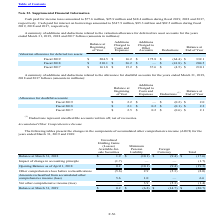According to Microchip Technology's financial document, What do deductions represent? uncollectible accounts written off, net of recoveries. The document states: "(1) Deductions represent uncollectible accounts written off, net of recoveries...." Also, What were the deductions in 2018? According to the financial document, (0.1) (in millions). The relevant text states: "Fiscal 2018 $ 2.1 $ 0.2 $ (0.1) $ 2.2..." Also, Which years does the table provide information for the additions and deductions related to the allowance for doubtful accounts? The document contains multiple relevant values: 2019, 2018, 2017. From the document: "on and $48.4 million during fiscal 2019, 2018 and 2017, on, $25.9 million and $48.4 million during fiscal 2019, 2018 and 2017, 5.9 million and $48.4 m..." Also, can you calculate: What was the change in the Balance at Beginning of Year between 2017 and 2018? Based on the calculation: 2.1-2.5, the result is -0.4 (in millions). This is based on the information: "s amounted to $347.9 million, $85.3 million and $82.5 million during fiscal 2019, 2018 and 2017, respectively. Fiscal 2019 $ 204.5 $ 16.2 $ 175.8 $ (64.4) $ 332.1..." The key data points involved are: 2.1, 2.5. Also, How many years did the balance at end of the year exceed $2 million? Counting the relevant items in the document: 2019, 2018, 2017, I find 3 instances. The key data points involved are: 2017, 2018, 2019. Also, can you calculate: What was the percentage change in the deductions between 2018 and 2019? To answer this question, I need to perform calculations using the financial data. The calculation is: (-0.2-(-0.1))/-0.1, which equals 100 (percentage). This is based on the information: "Fiscal 2019 $ 2.2 $ — $ (0.2) $ 2.0 Fiscal 2018 $ 210.1 $ 36.2 $ — $ (41.8) $ 204.5..." The key data points involved are: 0.1, 0.2. 